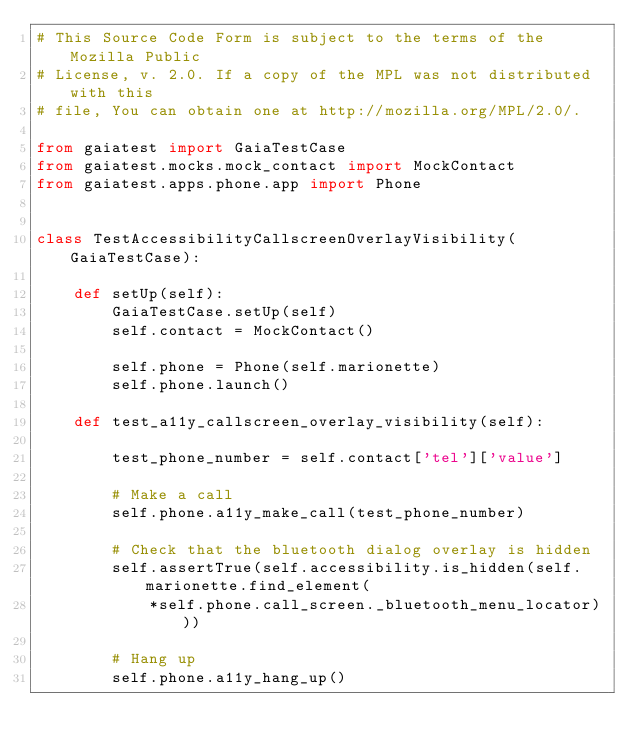<code> <loc_0><loc_0><loc_500><loc_500><_Python_># This Source Code Form is subject to the terms of the Mozilla Public
# License, v. 2.0. If a copy of the MPL was not distributed with this
# file, You can obtain one at http://mozilla.org/MPL/2.0/.

from gaiatest import GaiaTestCase
from gaiatest.mocks.mock_contact import MockContact
from gaiatest.apps.phone.app import Phone


class TestAccessibilityCallscreenOverlayVisibility(GaiaTestCase):

    def setUp(self):
        GaiaTestCase.setUp(self)
        self.contact = MockContact()

        self.phone = Phone(self.marionette)
        self.phone.launch()

    def test_a11y_callscreen_overlay_visibility(self):

        test_phone_number = self.contact['tel']['value']

        # Make a call
        self.phone.a11y_make_call(test_phone_number)

        # Check that the bluetooth dialog overlay is hidden
        self.assertTrue(self.accessibility.is_hidden(self.marionette.find_element(
            *self.phone.call_screen._bluetooth_menu_locator)))

        # Hang up
        self.phone.a11y_hang_up()
</code> 